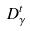Convert formula to latex. <formula><loc_0><loc_0><loc_500><loc_500>D _ { \gamma } ^ { t }</formula> 